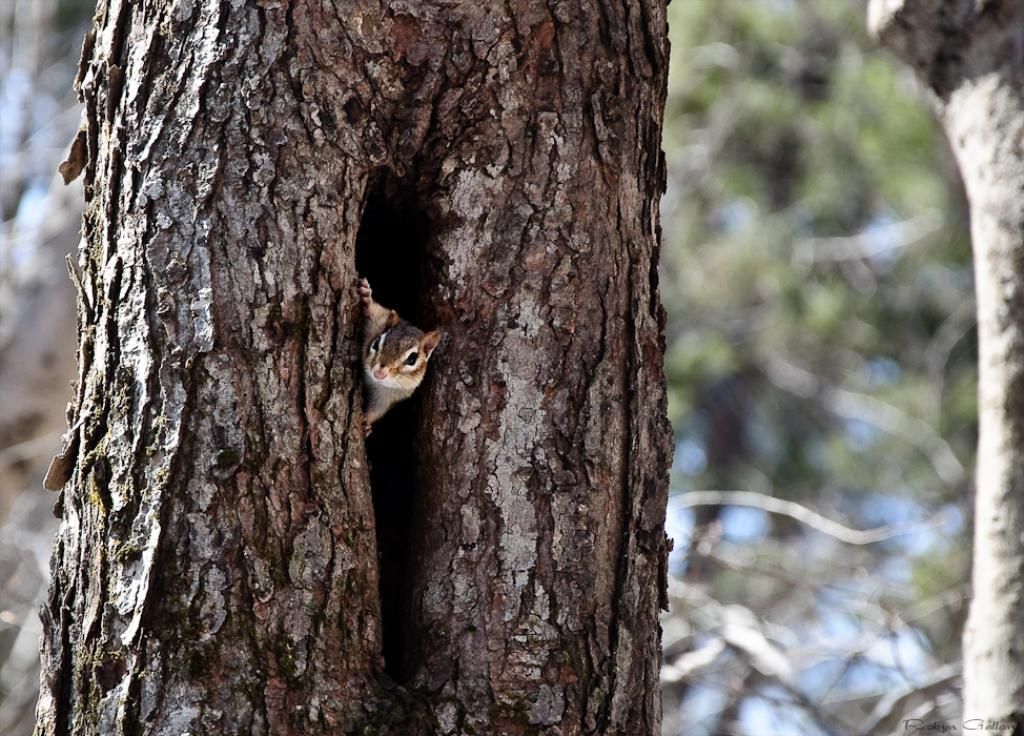What animal can be seen in the image? There is a squirrel in the image. Where is the squirrel located? The squirrel is on a tree trunk. Can you describe the background of the image? The background of the image is blurred. What type of hair can be seen on the squirrel in the image? There is no hair visible on the squirrel in the image, as squirrels have fur, not hair. 